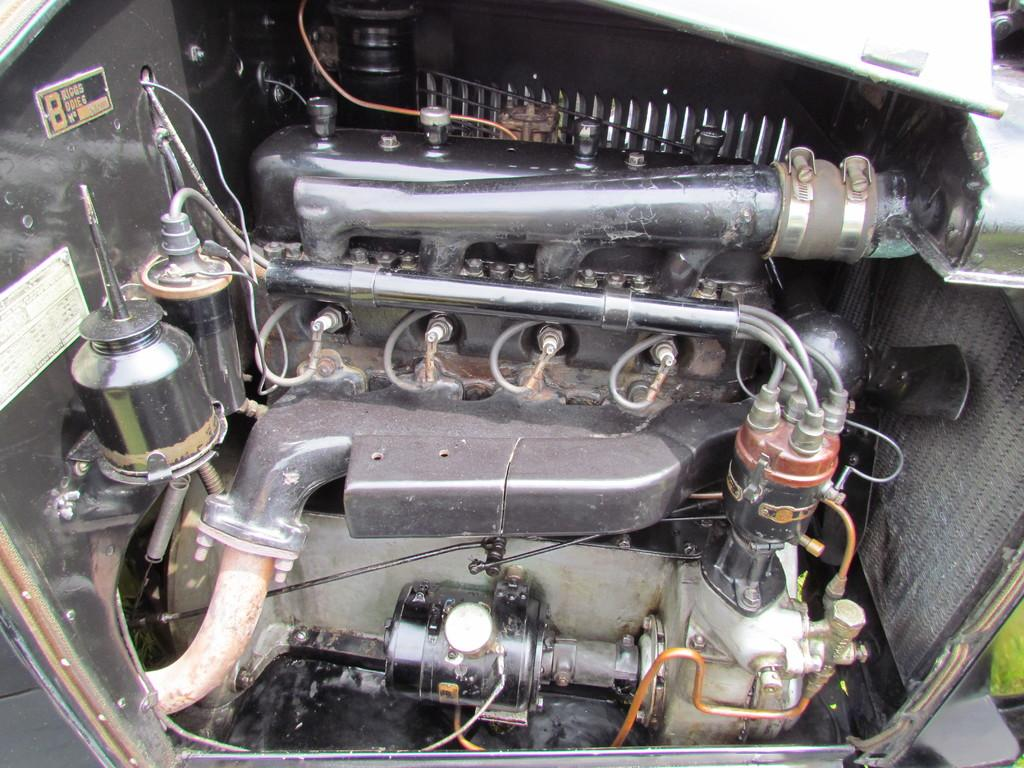What is the setting of the image? The image shows the inside of a vehicle. What types of objects can be seen in the image? There are pipes, wires, nuts and bolts, and a plate with writing in the image. Can you describe the plate with writing? The plate with writing is likely a label or identification tag for a specific part or component. Are there any other unspecified items in the image? Yes, there are other unspecified items in the image. In which direction is the butter facing in the image? There is no butter present in the image. Is there a gun visible in the image? No, there is no gun visible in the image. 